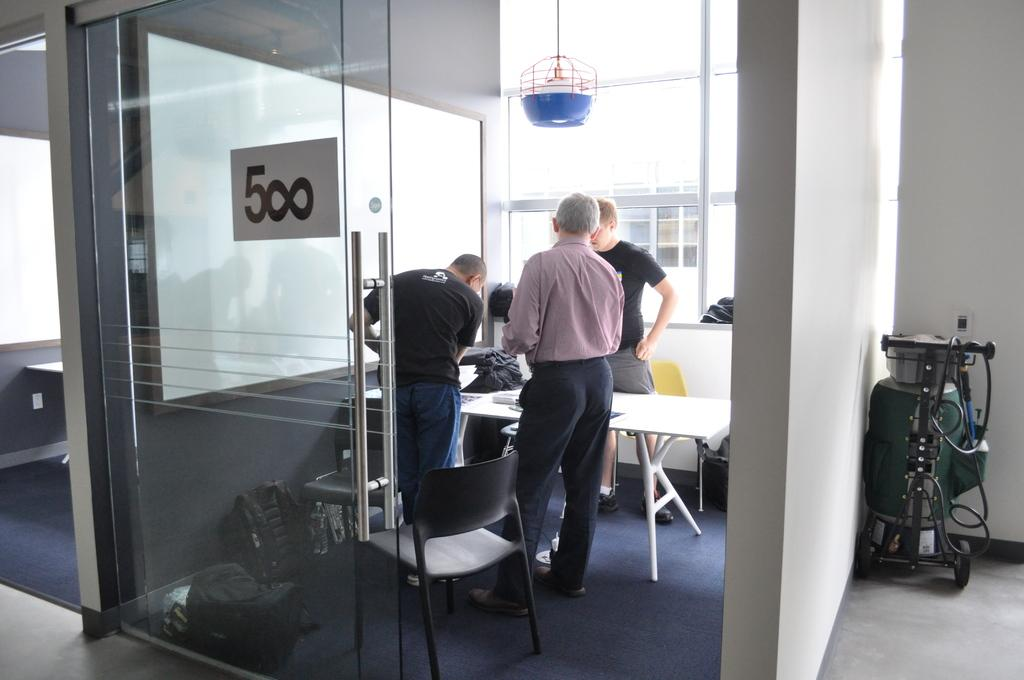Provide a one-sentence caption for the provided image. Employees discussing in meeting room 500 in their office. 